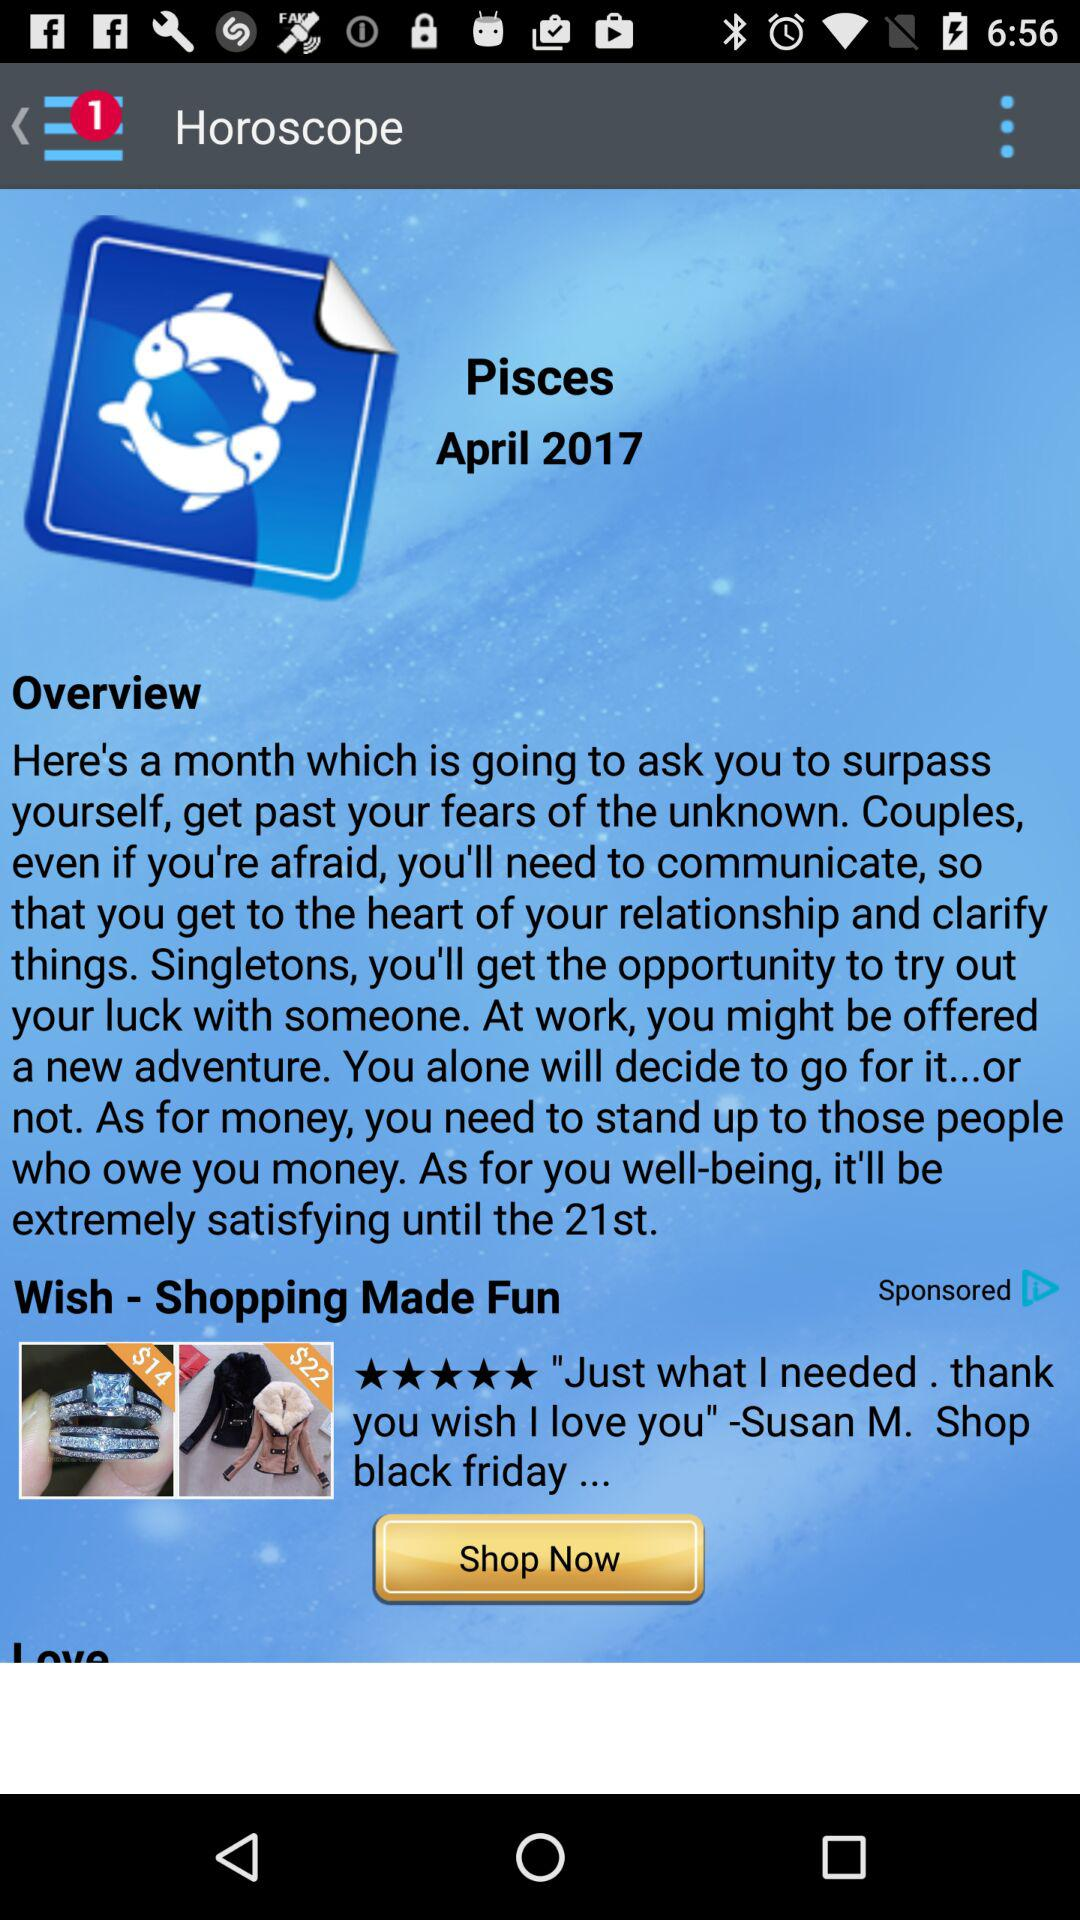What is the zodiac sign? The zodiac sign is Pisces. 